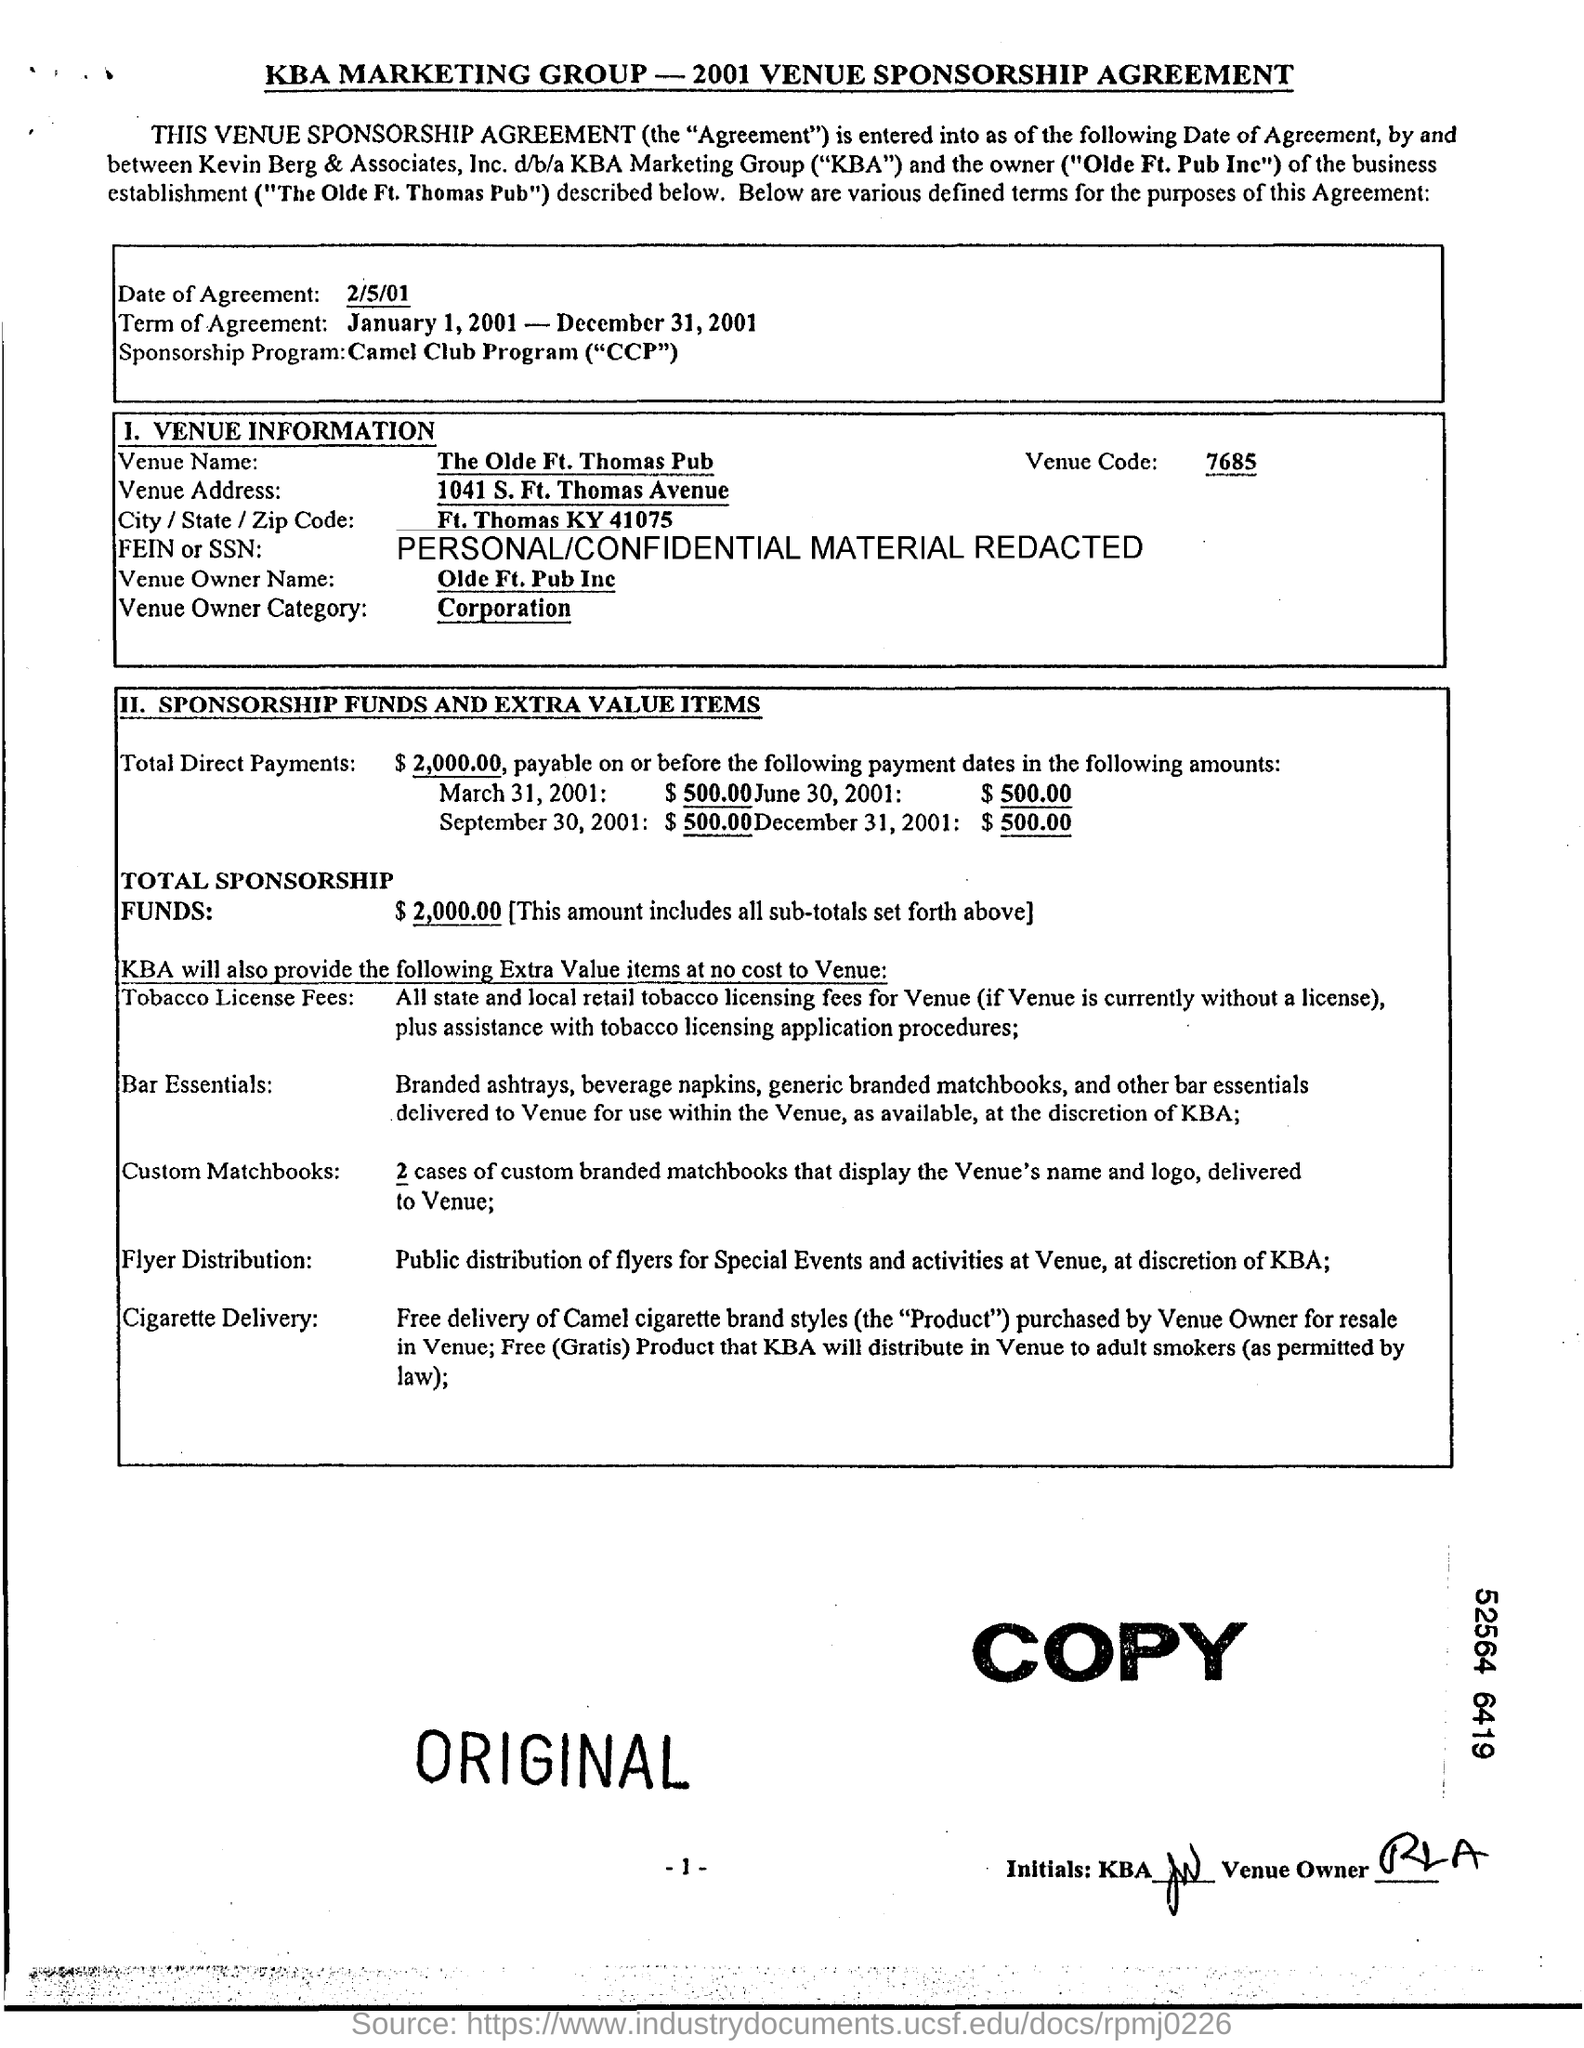Point out several critical features in this image. The full name of the venue owner is "Old Ft. Pub Inc. The Venue Owner category is a corporation. The Olde Ft. Thomas pub is the venue. 